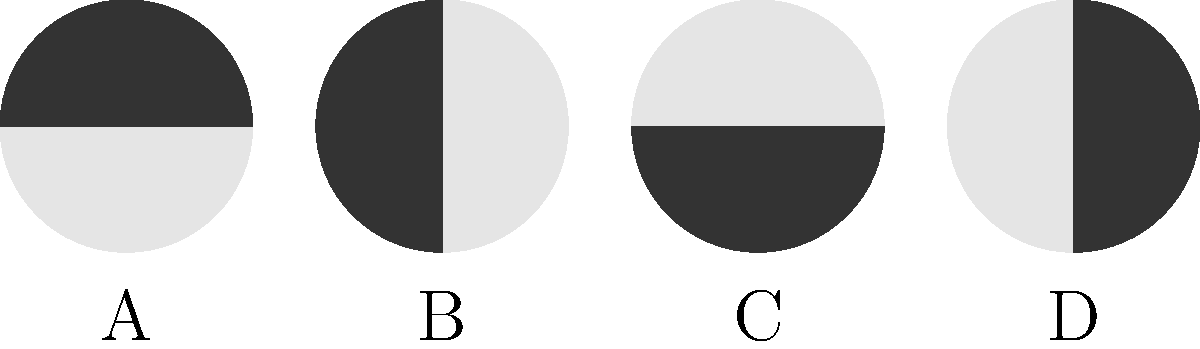As a parent interested in helping your child understand astronomy, you come across a diagram showing different phases of the Moon. Which phase represents the "First Quarter" moon? To answer this question, let's break down the Moon phases and their appearances:

1. The diagram shows four different phases of the Moon, labeled A, B, C, and D.

2. Moon phases are determined by the amount of the illuminated surface visible from Earth:
   - New Moon: Completely dark (not shown in the diagram)
   - Waxing Crescent: Right side partially illuminated
   - First Quarter: Right half fully illuminated
   - Waxing Gibbous: More than half illuminated, but not full
   - Full Moon: Completely illuminated
   - Waning Gibbous: More than half illuminated, but not full
   - Last Quarter: Left half fully illuminated
   - Waning Crescent: Left side partially illuminated

3. Analyzing the diagram:
   A: Full Moon (completely illuminated)
   B: First Quarter (right half illuminated)
   C: New Moon (completely dark)
   D: Last Quarter (left half illuminated)

4. The "First Quarter" moon occurs when the right half of the Moon is fully illuminated from our perspective on Earth.

5. In the diagram, this corresponds to the moon labeled B, where the right half is fully lit.

Therefore, the "First Quarter" moon is represented by the diagram labeled B.
Answer: B 